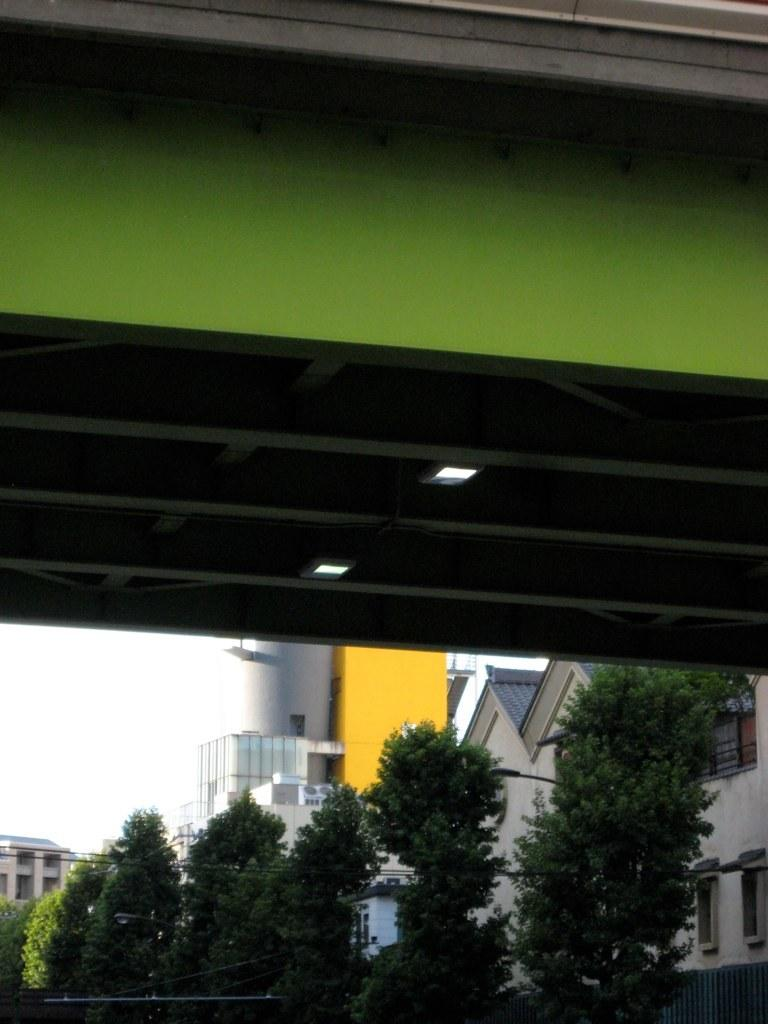What type of structure is present at the top of the image? There is a bridge in the image, and it is located at the top. What other objects or features can be seen in the image? There are trees and a building visible in the image. What is the position of the sky in the image? The sky is visible at the bottom of the image. What type of reward is being given to the duck in the image? There is no duck present in the image, and therefore no reward can be given to it. 